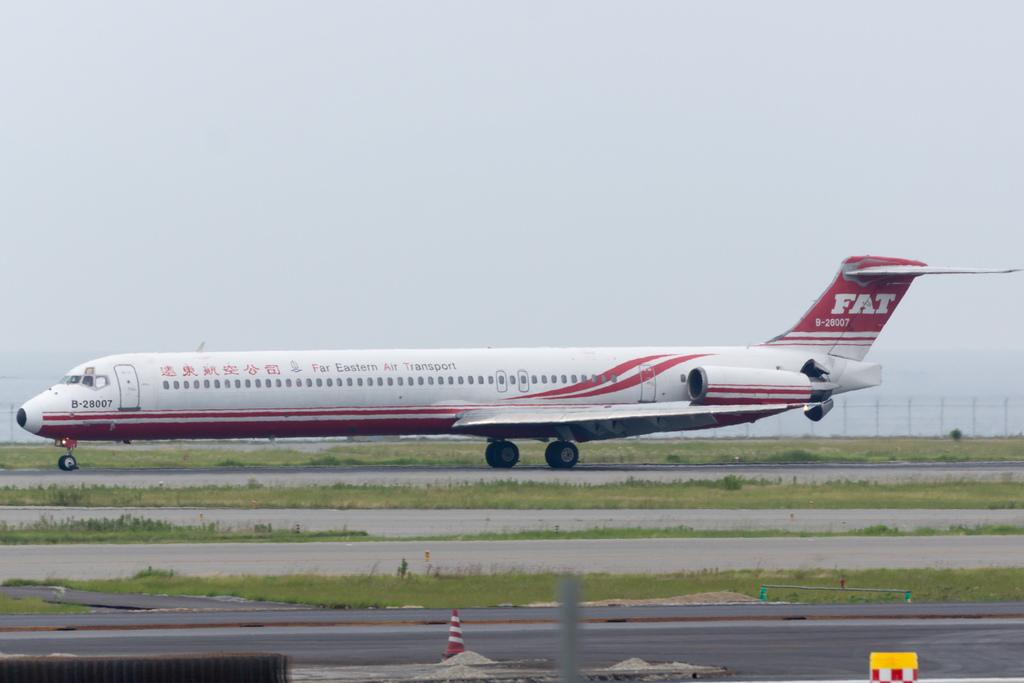In regards to the plane shown, what is fat an acronym for?
Give a very brief answer. Far eastern air transport. 